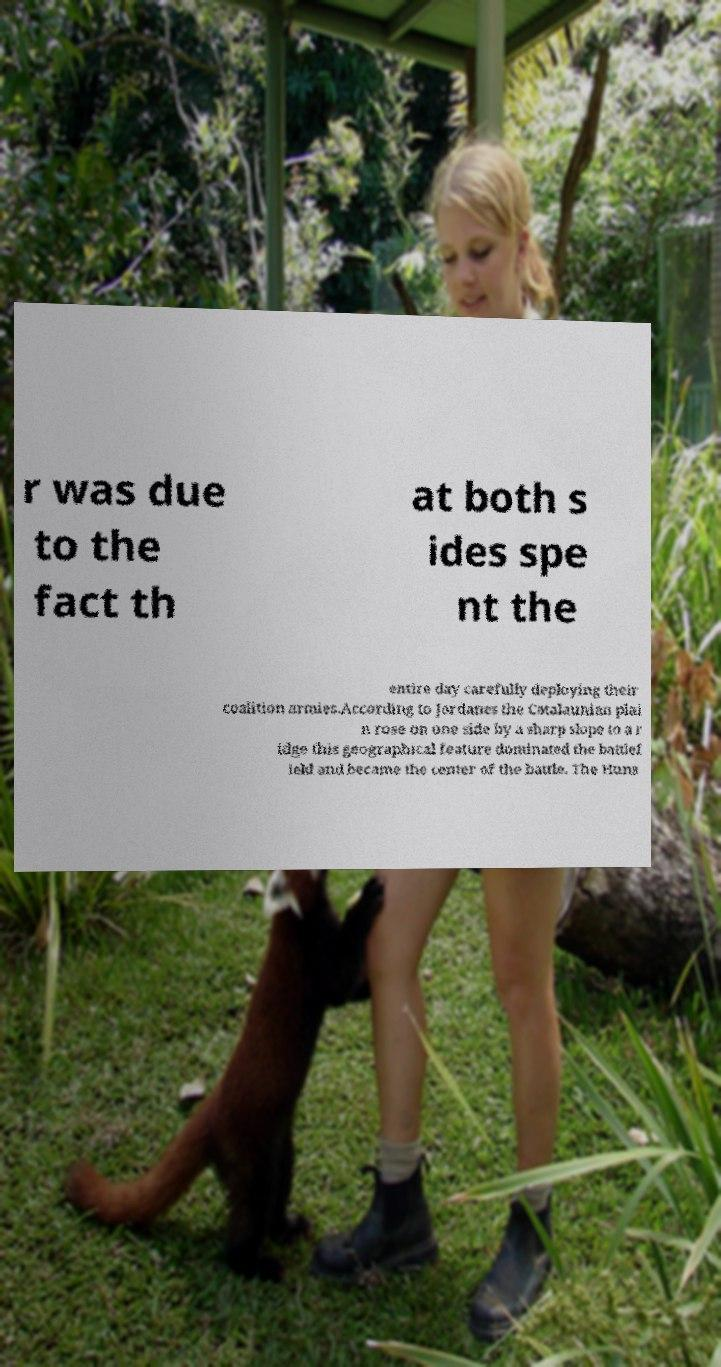What messages or text are displayed in this image? I need them in a readable, typed format. r was due to the fact th at both s ides spe nt the entire day carefully deploying their coalition armies.According to Jordanes the Catalaunian plai n rose on one side by a sharp slope to a r idge this geographical feature dominated the battlef ield and became the center of the battle. The Huns 